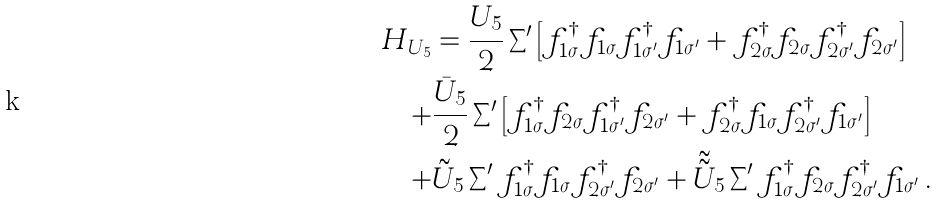<formula> <loc_0><loc_0><loc_500><loc_500>H _ { U _ { 5 } } & = \frac { U _ { 5 } } { 2 } \sum \nolimits ^ { \prime } \left [ f _ { 1 \sigma } ^ { \dag } f _ { 1 \sigma } f _ { 1 \sigma ^ { \prime } } ^ { \dag } f _ { 1 \sigma ^ { \prime } } + f _ { 2 \sigma } ^ { \dag } f _ { 2 \sigma } f _ { 2 \sigma ^ { \prime } } ^ { \dag } f _ { 2 \sigma ^ { \prime } } \right ] \\ + & \frac { \bar { U } _ { 5 } } { 2 } \sum \nolimits ^ { \prime } \left [ f _ { 1 \sigma } ^ { \dag } f _ { 2 \sigma } f _ { 1 \sigma ^ { \prime } } ^ { \dag } f _ { 2 \sigma ^ { \prime } } + f _ { 2 \sigma } ^ { \dag } f _ { 1 \sigma } f _ { 2 \sigma ^ { \prime } } ^ { \dag } f _ { 1 \sigma ^ { \prime } } \right ] \\ + & \tilde { U } _ { 5 } \sum \nolimits ^ { \prime } f _ { 1 \sigma } ^ { \dag } f _ { 1 \sigma } f _ { 2 \sigma ^ { \prime } } ^ { \dag } f _ { 2 \sigma ^ { \prime } } + \tilde { \tilde { U } } _ { 5 } \sum \nolimits ^ { \prime } f _ { 1 \sigma } ^ { \dag } f _ { 2 \sigma } f _ { 2 \sigma ^ { \prime } } ^ { \dag } f _ { 1 \sigma ^ { \prime } } \, .</formula> 